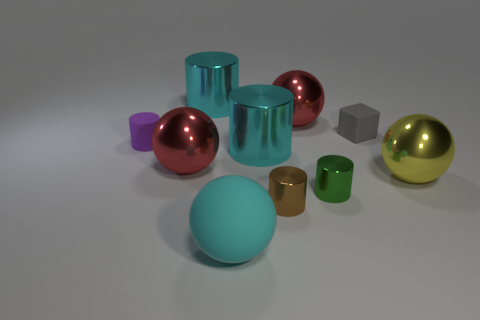Are there fewer tiny purple rubber cylinders than large cyan cylinders?
Provide a succinct answer. Yes. There is a shiny ball that is left of the large shiny sphere that is behind the small matte cube; what is its size?
Ensure brevity in your answer.  Large. What is the shape of the big cyan metal object behind the cyan metal cylinder that is right of the sphere that is in front of the small green cylinder?
Provide a succinct answer. Cylinder. The tiny cube that is the same material as the small purple object is what color?
Provide a short and direct response. Gray. There is a tiny metallic cylinder that is right of the large red metallic thing to the right of the small object in front of the green thing; what color is it?
Provide a succinct answer. Green. What number of cubes are either small gray rubber objects or large yellow shiny objects?
Ensure brevity in your answer.  1. There is a big rubber sphere; is its color the same as the tiny matte object right of the small rubber cylinder?
Your response must be concise. No. What is the color of the matte block?
Offer a terse response. Gray. What number of objects are big cyan shiny objects or tiny brown objects?
Offer a very short reply. 3. What material is the purple cylinder that is the same size as the cube?
Provide a short and direct response. Rubber. 